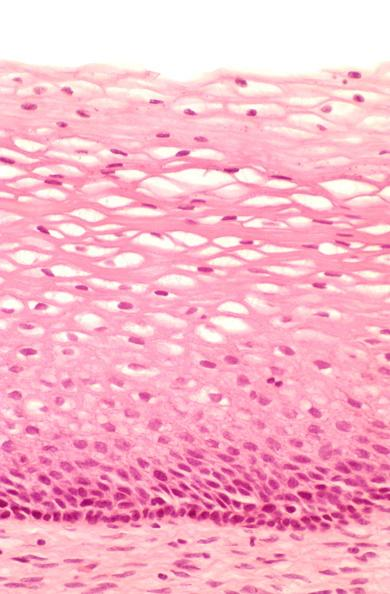what does this image show?
Answer the question using a single word or phrase. Cervix 